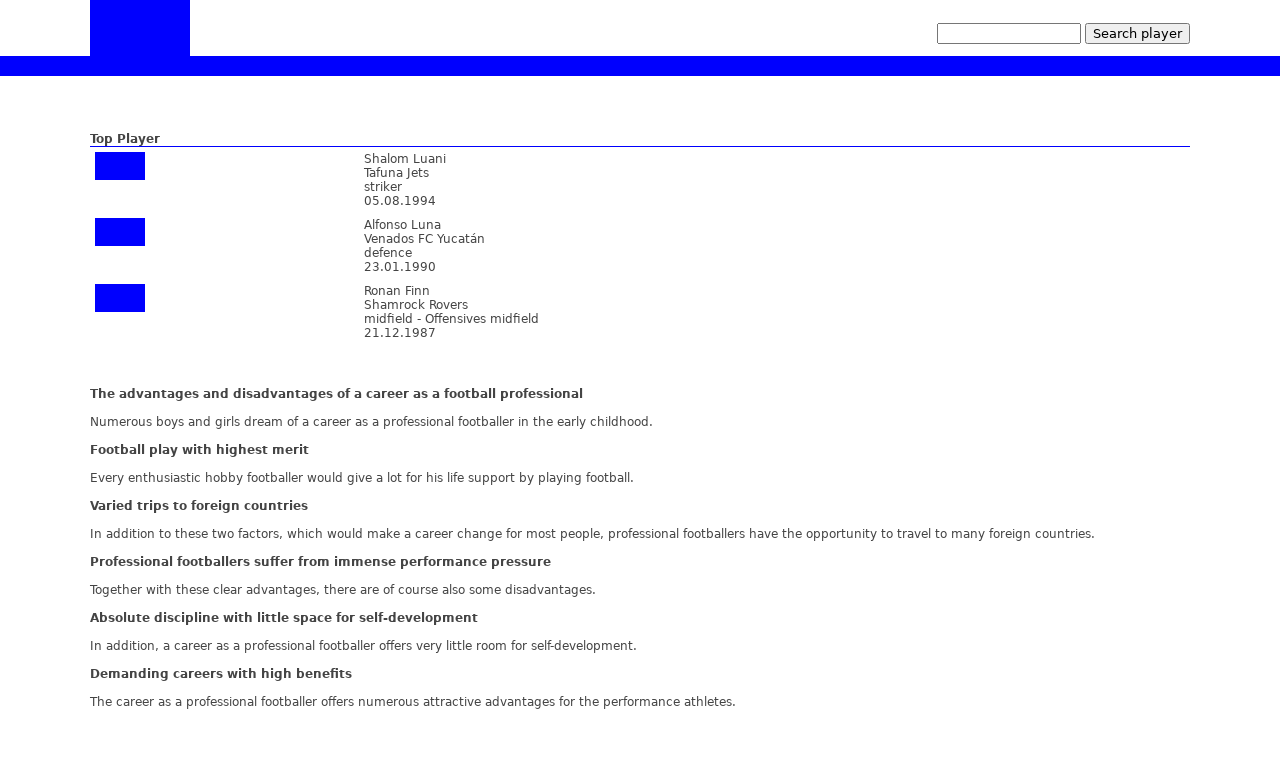Could you tell me about the impact of a professional football career as outlined on this website? The website outlines both the advantages and disadvantages of a career as a professional footballer. It mentions that a career in football can allow for varied international travel and brings significant monetary benefits. However, it also highlights the negatives such as intense performance pressure and limited personal growth outside of sports. Essentially, it portrays a mixed yet realistic view of what one can expect from pursuing this path. 